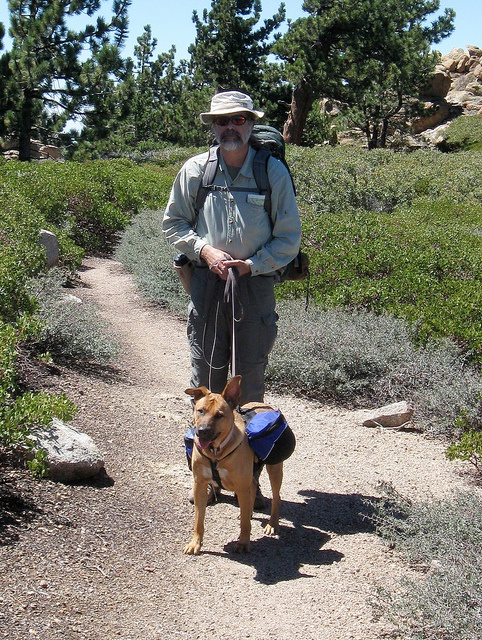Describe the objects in this image and their specific colors. I can see people in lightblue, black, gray, darkgray, and lightgray tones, dog in lightblue, maroon, black, and gray tones, and backpack in lightblue, black, gray, darkgray, and lightgray tones in this image. 